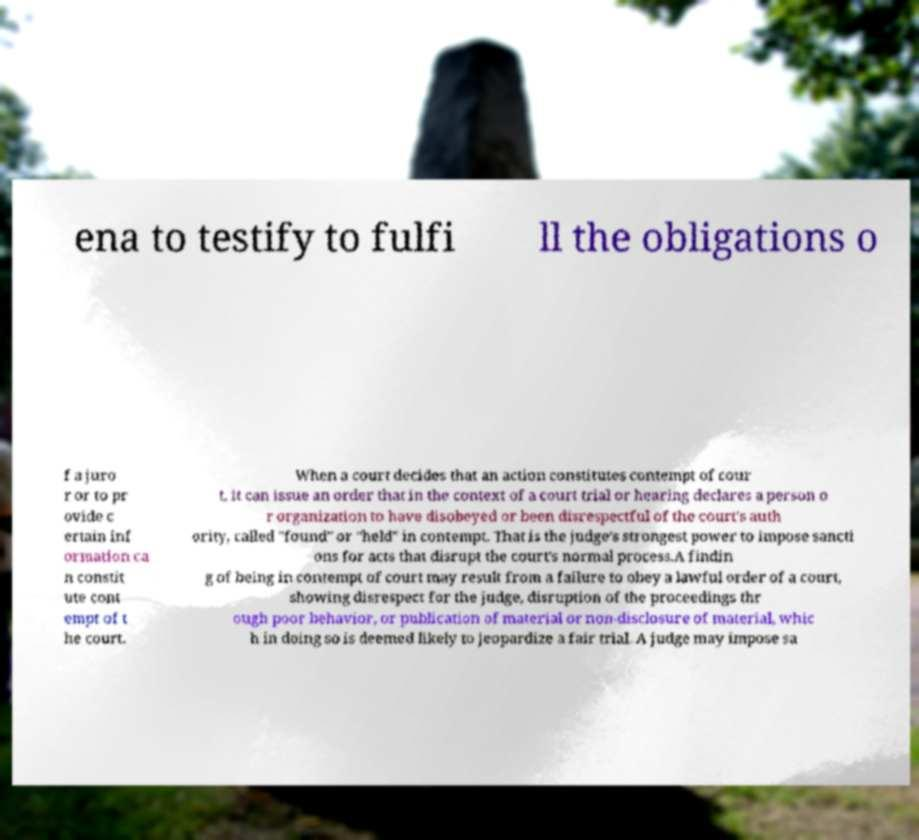For documentation purposes, I need the text within this image transcribed. Could you provide that? ena to testify to fulfi ll the obligations o f a juro r or to pr ovide c ertain inf ormation ca n constit ute cont empt of t he court. When a court decides that an action constitutes contempt of cour t, it can issue an order that in the context of a court trial or hearing declares a person o r organization to have disobeyed or been disrespectful of the court's auth ority, called "found" or "held" in contempt. That is the judge's strongest power to impose sancti ons for acts that disrupt the court's normal process.A findin g of being in contempt of court may result from a failure to obey a lawful order of a court, showing disrespect for the judge, disruption of the proceedings thr ough poor behavior, or publication of material or non-disclosure of material, whic h in doing so is deemed likely to jeopardize a fair trial. A judge may impose sa 